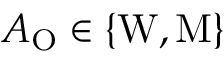Convert formula to latex. <formula><loc_0><loc_0><loc_500><loc_500>A _ { O } \in \{ W , M \}</formula> 